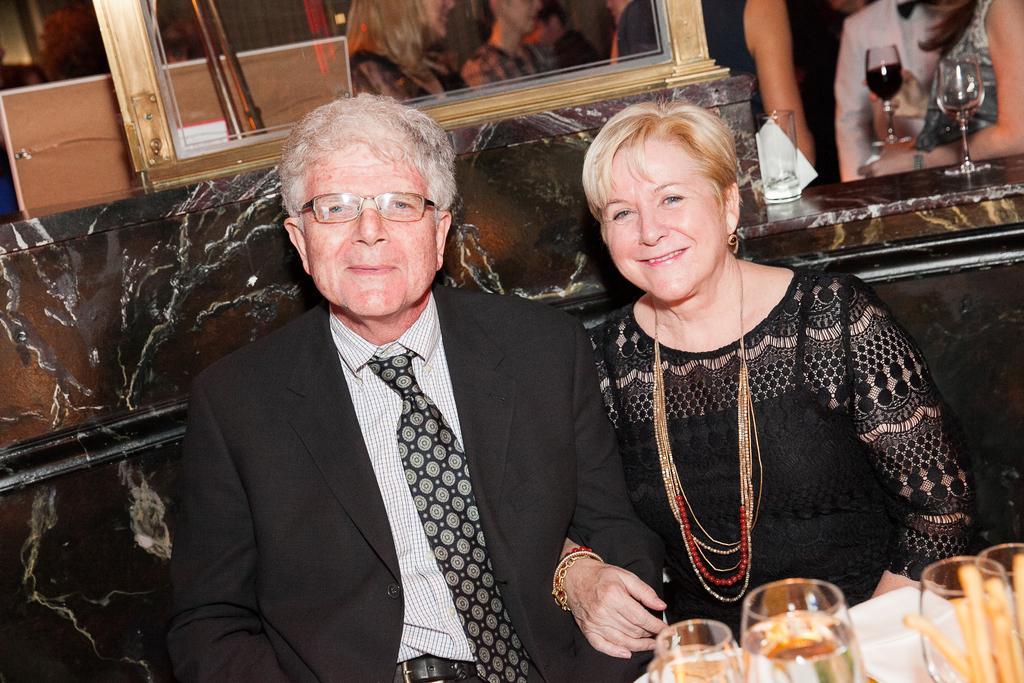Can you describe this image briefly? In this picture i could see two persons sitting wearing a formal blazer and tie and the other lady is wearing a frock and with jewelry. In the right corner there is wine glass with wine filled in, in the back ground there are many number of people. 